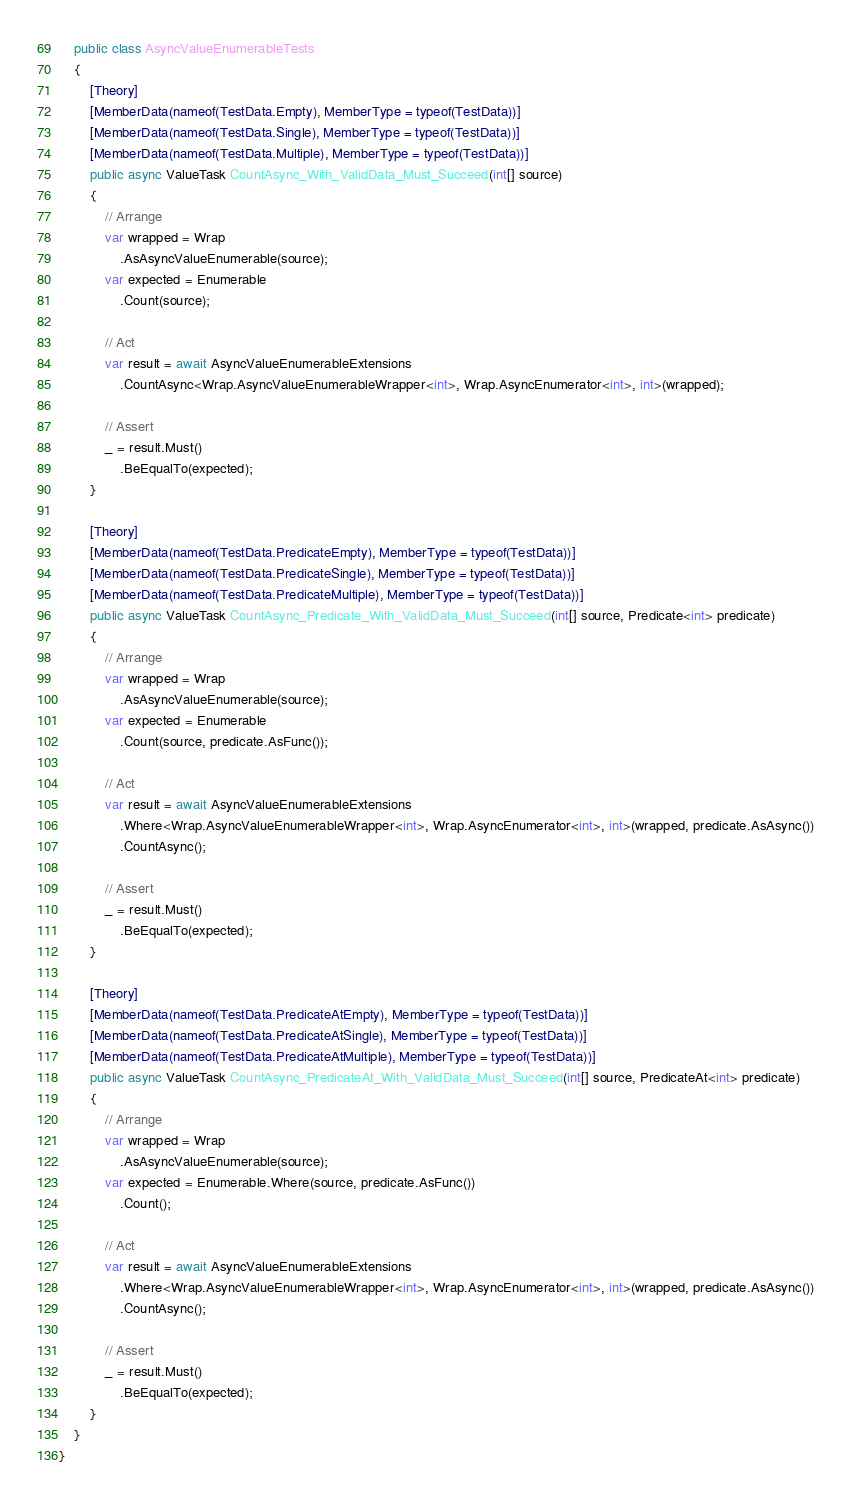<code> <loc_0><loc_0><loc_500><loc_500><_C#_>    public class AsyncValueEnumerableTests
    {
        [Theory]
        [MemberData(nameof(TestData.Empty), MemberType = typeof(TestData))]
        [MemberData(nameof(TestData.Single), MemberType = typeof(TestData))]
        [MemberData(nameof(TestData.Multiple), MemberType = typeof(TestData))]
        public async ValueTask CountAsync_With_ValidData_Must_Succeed(int[] source)
        {
            // Arrange
            var wrapped = Wrap
                .AsAsyncValueEnumerable(source);
            var expected = Enumerable
                .Count(source);

            // Act
            var result = await AsyncValueEnumerableExtensions
                .CountAsync<Wrap.AsyncValueEnumerableWrapper<int>, Wrap.AsyncEnumerator<int>, int>(wrapped);

            // Assert
            _ = result.Must()
                .BeEqualTo(expected);
        }

        [Theory]
        [MemberData(nameof(TestData.PredicateEmpty), MemberType = typeof(TestData))]
        [MemberData(nameof(TestData.PredicateSingle), MemberType = typeof(TestData))]
        [MemberData(nameof(TestData.PredicateMultiple), MemberType = typeof(TestData))]
        public async ValueTask CountAsync_Predicate_With_ValidData_Must_Succeed(int[] source, Predicate<int> predicate)
        {
            // Arrange
            var wrapped = Wrap
                .AsAsyncValueEnumerable(source);
            var expected = Enumerable
                .Count(source, predicate.AsFunc());

            // Act
            var result = await AsyncValueEnumerableExtensions
                .Where<Wrap.AsyncValueEnumerableWrapper<int>, Wrap.AsyncEnumerator<int>, int>(wrapped, predicate.AsAsync())
                .CountAsync();

            // Assert
            _ = result.Must()
                .BeEqualTo(expected);
        }

        [Theory]
        [MemberData(nameof(TestData.PredicateAtEmpty), MemberType = typeof(TestData))]
        [MemberData(nameof(TestData.PredicateAtSingle), MemberType = typeof(TestData))]
        [MemberData(nameof(TestData.PredicateAtMultiple), MemberType = typeof(TestData))]
        public async ValueTask CountAsync_PredicateAt_With_ValidData_Must_Succeed(int[] source, PredicateAt<int> predicate)
        {
            // Arrange
            var wrapped = Wrap
                .AsAsyncValueEnumerable(source);
            var expected = Enumerable.Where(source, predicate.AsFunc())
                .Count();

            // Act
            var result = await AsyncValueEnumerableExtensions
                .Where<Wrap.AsyncValueEnumerableWrapper<int>, Wrap.AsyncEnumerator<int>, int>(wrapped, predicate.AsAsync())
                .CountAsync();

            // Assert
            _ = result.Must()
                .BeEqualTo(expected);
        }
    }
}</code> 